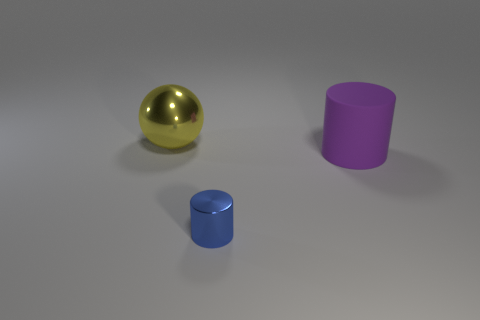How would you describe the lighting in this scene? The lighting in the scene is soft and diffused, casting gentle shadows and highlights, which gives the objects a three-dimensional appearance and a calm ambiance. Does the lighting affect the color perception of the objects? Absolutely, soft lighting can enhance color saturation slightly, making the objects' colors appear deeper and richer without harsh glares or reflections. 